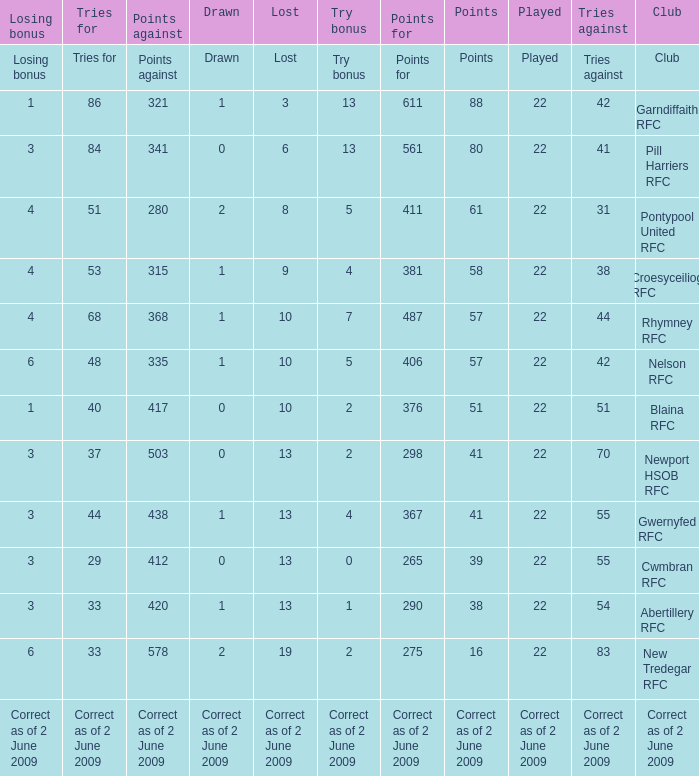Which club has 275 points? New Tredegar RFC. 